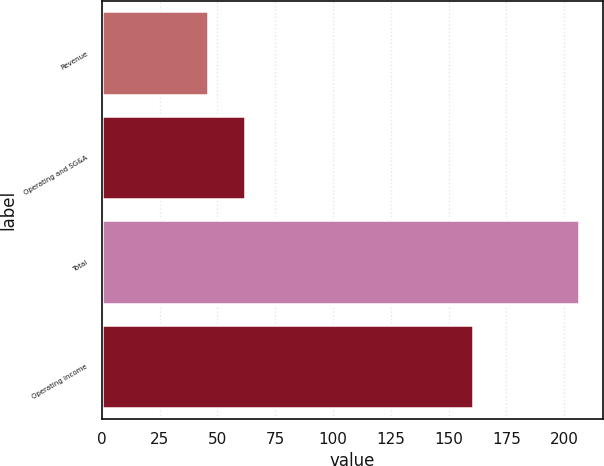Convert chart to OTSL. <chart><loc_0><loc_0><loc_500><loc_500><bar_chart><fcel>Revenue<fcel>Operating and SG&A<fcel>Total<fcel>Operating income<nl><fcel>45.8<fcel>61.86<fcel>206.4<fcel>160.6<nl></chart> 